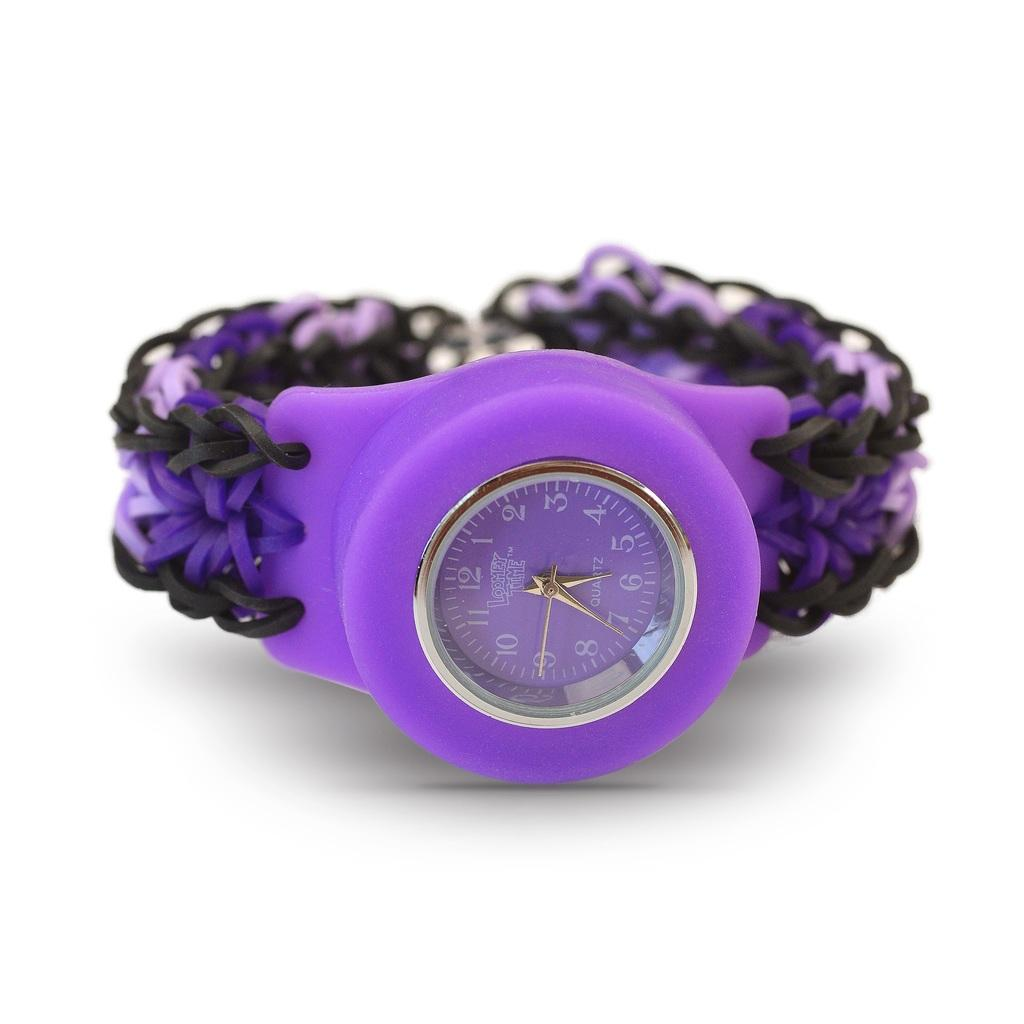<image>
Describe the image concisely. A purple Loomey Time watch has gold colored hands. 